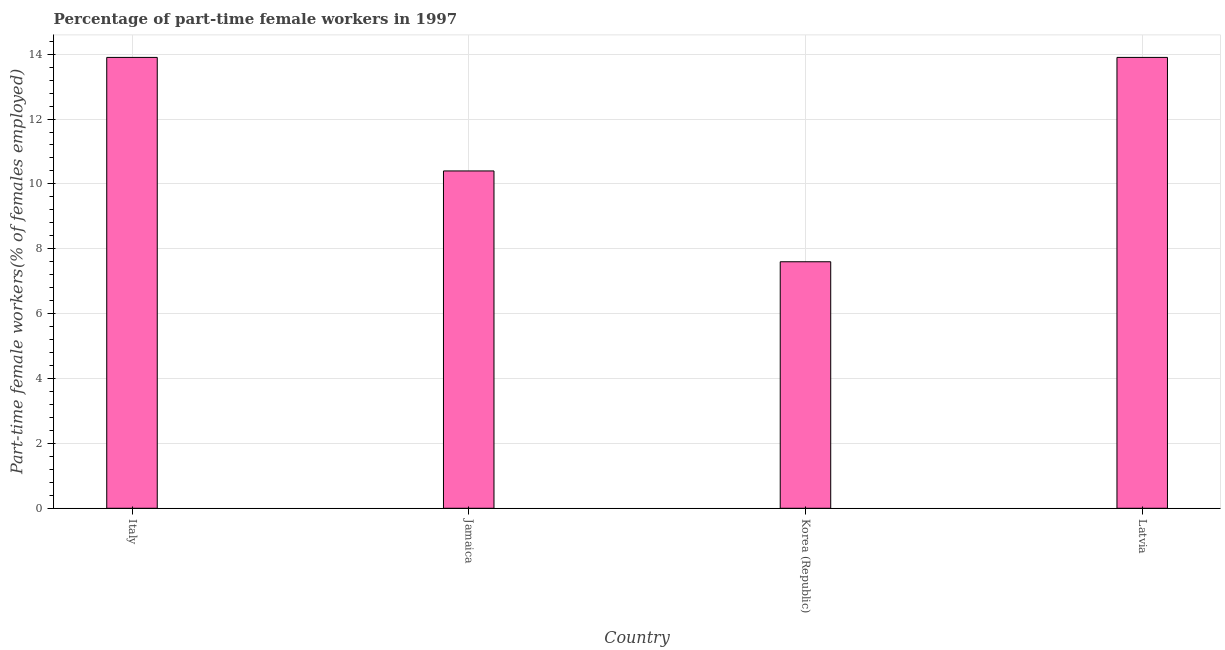Does the graph contain any zero values?
Ensure brevity in your answer.  No. What is the title of the graph?
Make the answer very short. Percentage of part-time female workers in 1997. What is the label or title of the Y-axis?
Your answer should be compact. Part-time female workers(% of females employed). What is the percentage of part-time female workers in Jamaica?
Offer a terse response. 10.4. Across all countries, what is the maximum percentage of part-time female workers?
Your answer should be very brief. 13.9. Across all countries, what is the minimum percentage of part-time female workers?
Keep it short and to the point. 7.6. In which country was the percentage of part-time female workers minimum?
Your response must be concise. Korea (Republic). What is the sum of the percentage of part-time female workers?
Keep it short and to the point. 45.8. What is the difference between the percentage of part-time female workers in Jamaica and Korea (Republic)?
Give a very brief answer. 2.8. What is the average percentage of part-time female workers per country?
Your answer should be very brief. 11.45. What is the median percentage of part-time female workers?
Keep it short and to the point. 12.15. In how many countries, is the percentage of part-time female workers greater than 9.2 %?
Your response must be concise. 3. What is the ratio of the percentage of part-time female workers in Korea (Republic) to that in Latvia?
Give a very brief answer. 0.55. What is the difference between the highest and the second highest percentage of part-time female workers?
Keep it short and to the point. 0. What is the difference between the highest and the lowest percentage of part-time female workers?
Keep it short and to the point. 6.3. Are all the bars in the graph horizontal?
Make the answer very short. No. How many countries are there in the graph?
Offer a very short reply. 4. Are the values on the major ticks of Y-axis written in scientific E-notation?
Give a very brief answer. No. What is the Part-time female workers(% of females employed) in Italy?
Your answer should be compact. 13.9. What is the Part-time female workers(% of females employed) in Jamaica?
Your response must be concise. 10.4. What is the Part-time female workers(% of females employed) of Korea (Republic)?
Your response must be concise. 7.6. What is the Part-time female workers(% of females employed) in Latvia?
Provide a succinct answer. 13.9. What is the difference between the Part-time female workers(% of females employed) in Italy and Korea (Republic)?
Give a very brief answer. 6.3. What is the difference between the Part-time female workers(% of females employed) in Italy and Latvia?
Your answer should be very brief. 0. What is the difference between the Part-time female workers(% of females employed) in Jamaica and Korea (Republic)?
Keep it short and to the point. 2.8. What is the difference between the Part-time female workers(% of females employed) in Korea (Republic) and Latvia?
Provide a short and direct response. -6.3. What is the ratio of the Part-time female workers(% of females employed) in Italy to that in Jamaica?
Your answer should be very brief. 1.34. What is the ratio of the Part-time female workers(% of females employed) in Italy to that in Korea (Republic)?
Your answer should be compact. 1.83. What is the ratio of the Part-time female workers(% of females employed) in Italy to that in Latvia?
Give a very brief answer. 1. What is the ratio of the Part-time female workers(% of females employed) in Jamaica to that in Korea (Republic)?
Provide a short and direct response. 1.37. What is the ratio of the Part-time female workers(% of females employed) in Jamaica to that in Latvia?
Provide a succinct answer. 0.75. What is the ratio of the Part-time female workers(% of females employed) in Korea (Republic) to that in Latvia?
Make the answer very short. 0.55. 